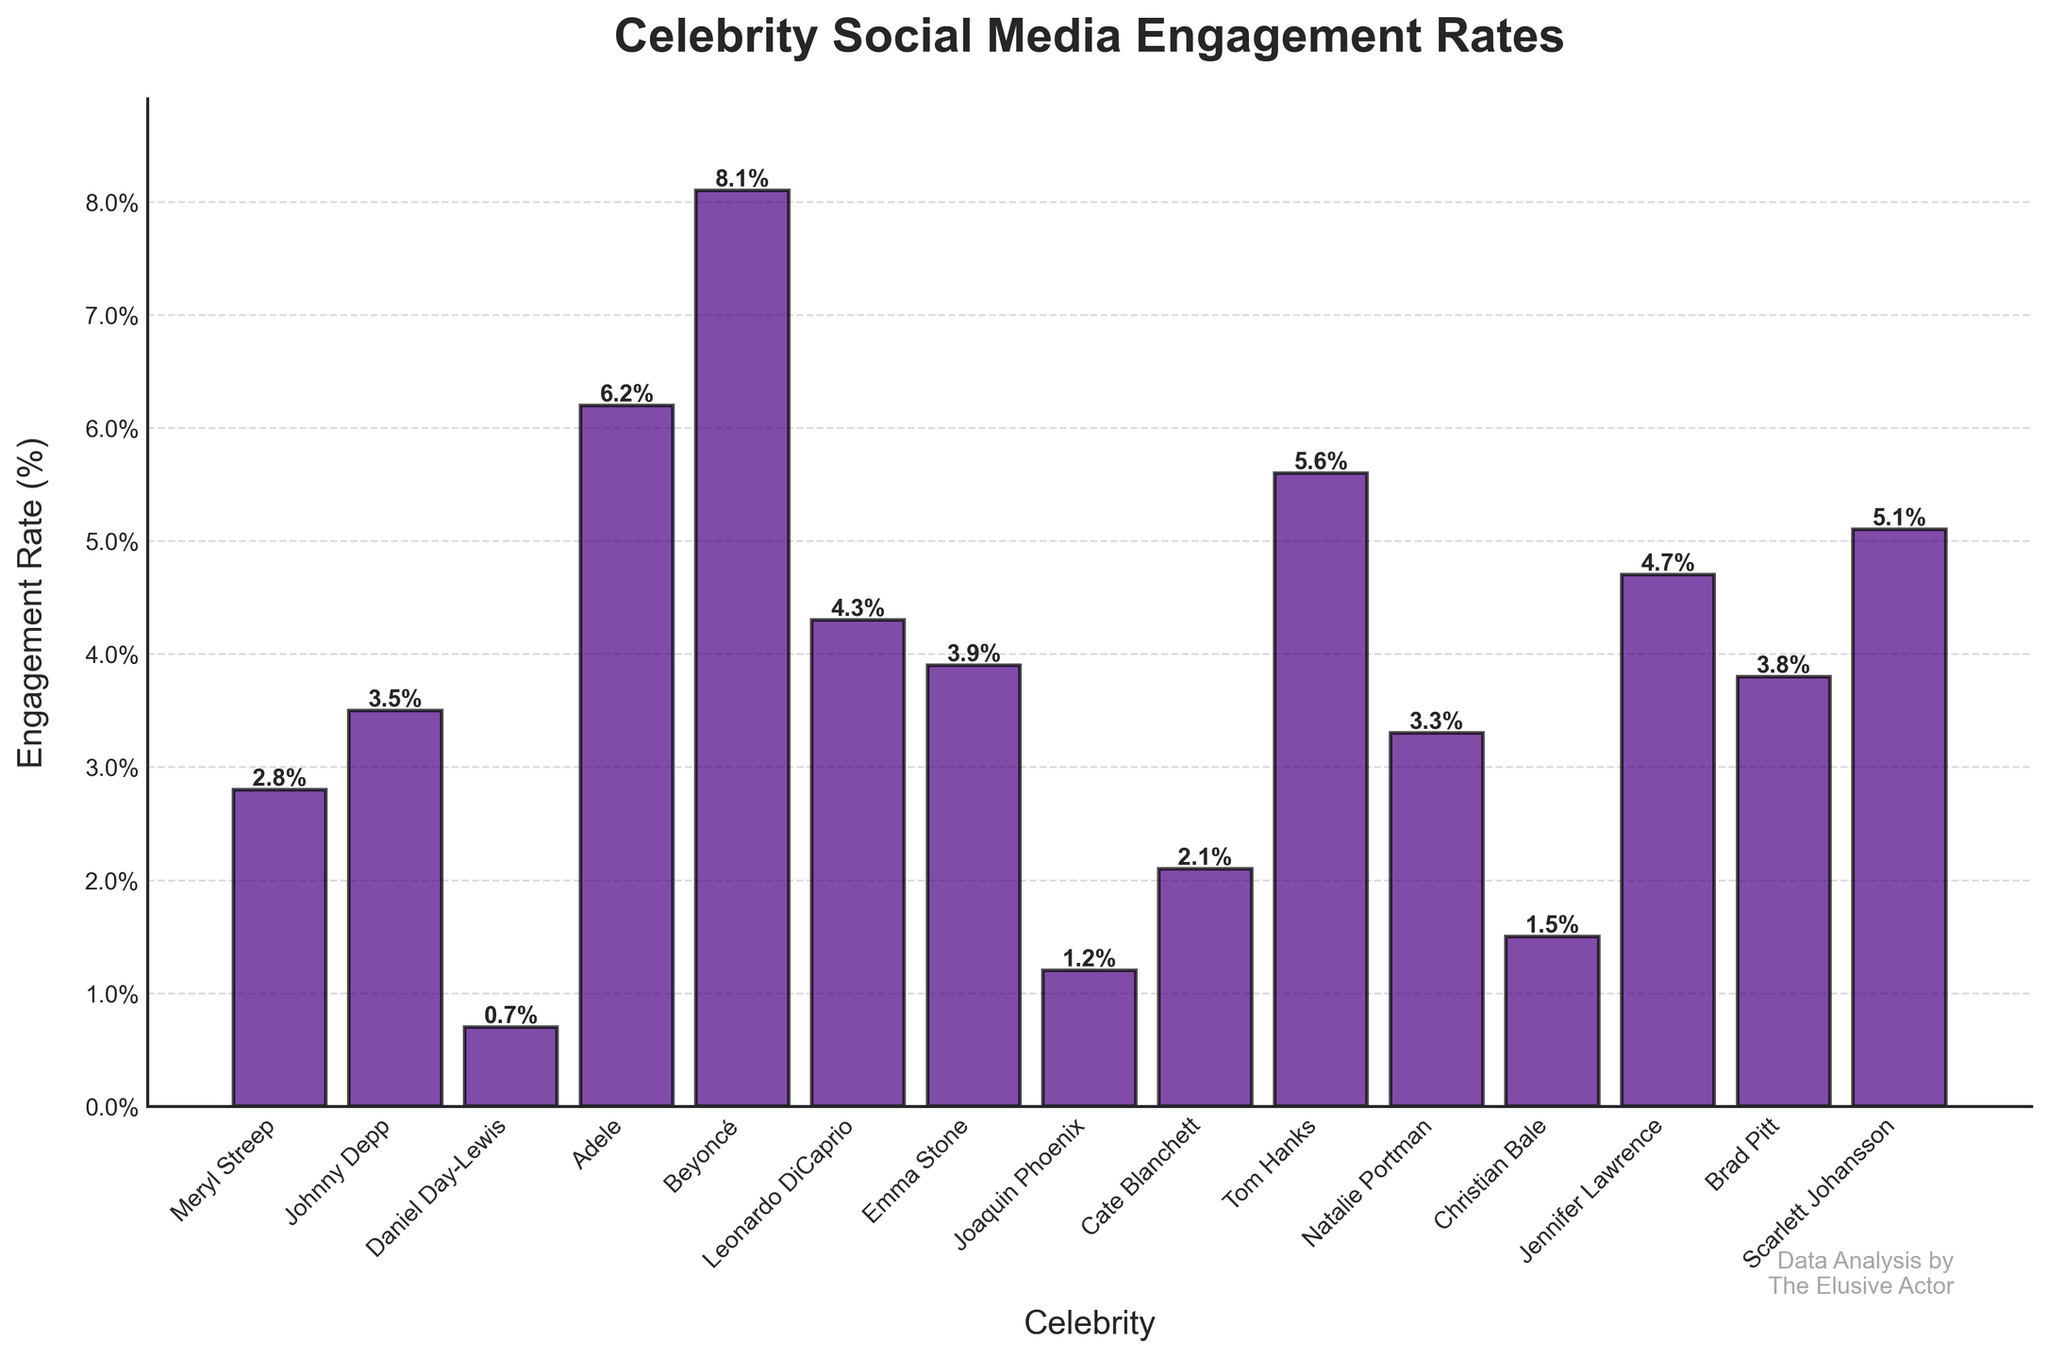Which celebrity has the highest social media engagement rate? By looking at the height of the bars, Beyoncé has the highest bar, indicating the highest engagement rate at 8.1%.
Answer: Beyoncé What is the difference in social media engagement rate between Leonardo DiCaprio and Jennifer Lawrence? The engagement rate for Leonardo DiCaprio is 4.3% and for Jennifer Lawrence is 4.7%. The difference is calculated by subtracting 4.3% from 4.7%, which equals 0.4%.
Answer: 0.4% Which celebrity has an engagement rate closest to 3.5%? By looking at the bars labeled with their respective engagement rates, Johnny Depp has an engagement rate of 3.5%.
Answer: Johnny Depp How many celebrities have a social media engagement rate higher than 5%? By inspecting the bars, Beyoncé, Adele, Tom Hanks, and Scarlett Johansson have rates higher than 5%. There are 4 such celebrities.
Answer: 4 What's the sum of the engagement rates for Cate Blanchett and Joaquin Phoenix? Cate Blanchett has an engagement rate of 2.1% and Joaquin Phoenix has an engagement rate of 1.2%. Adding these together results in 3.3%.
Answer: 3.3% Which has a higher engagement rate, Emma Stone or Natalie Portman? By comparing the height of the two bars, Emma Stone has an engagement rate of 3.9%, while Natalie Portman has 3.3%. Emma Stone’s engagement rate is higher.
Answer: Emma Stone What is the average engagement rate for the celebrities shown? Add all engagement rates (total = 60.8%) and divide by the number of celebrities (15). 60.8% / 15 = 4.053%.
Answer: 4.1% (rounded to one decimal place) Is the engagement rate for Meryl Streep closer to the rate of Cate Blanchett or Christian Bale? Meryl Streep has an engagement rate of 2.8%, Cate Blanchett has 2.1%, and Christian Bale has 1.5%. The difference for Cate Blanchett is 0.7% (2.8% - 2.1%), and for Christian Bale, it is 1.3% (2.8% - 1.5%). Meryl Streep's rate is closer to Cate Blanchett's.
Answer: Cate Blanchett Which celebrity has the lowest engagement rate? By noting the shortest bar, Daniel Day-Lewis has the lowest engagement rate at 0.7%.
Answer: Daniel Day-Lewis How much higher is Brad Pitt's engagement rate compared to Christian Bale's? Brad Pitt's rate is 3.8% and Christian Bale's is 1.5%. Subtracting Christian Bale's rate from Brad Pitt's rate gives 2.3%.
Answer: 2.3% 